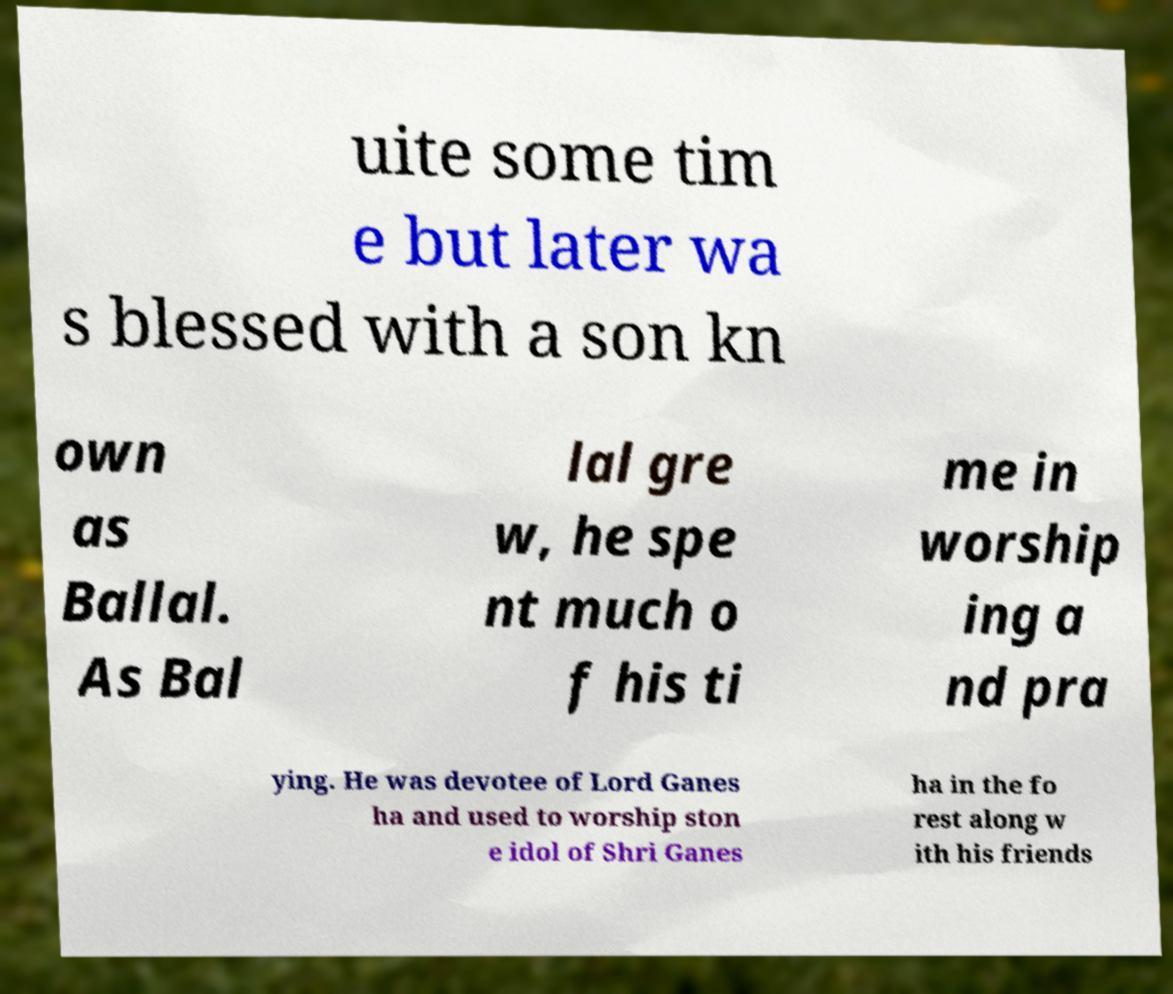Could you assist in decoding the text presented in this image and type it out clearly? uite some tim e but later wa s blessed with a son kn own as Ballal. As Bal lal gre w, he spe nt much o f his ti me in worship ing a nd pra ying. He was devotee of Lord Ganes ha and used to worship ston e idol of Shri Ganes ha in the fo rest along w ith his friends 